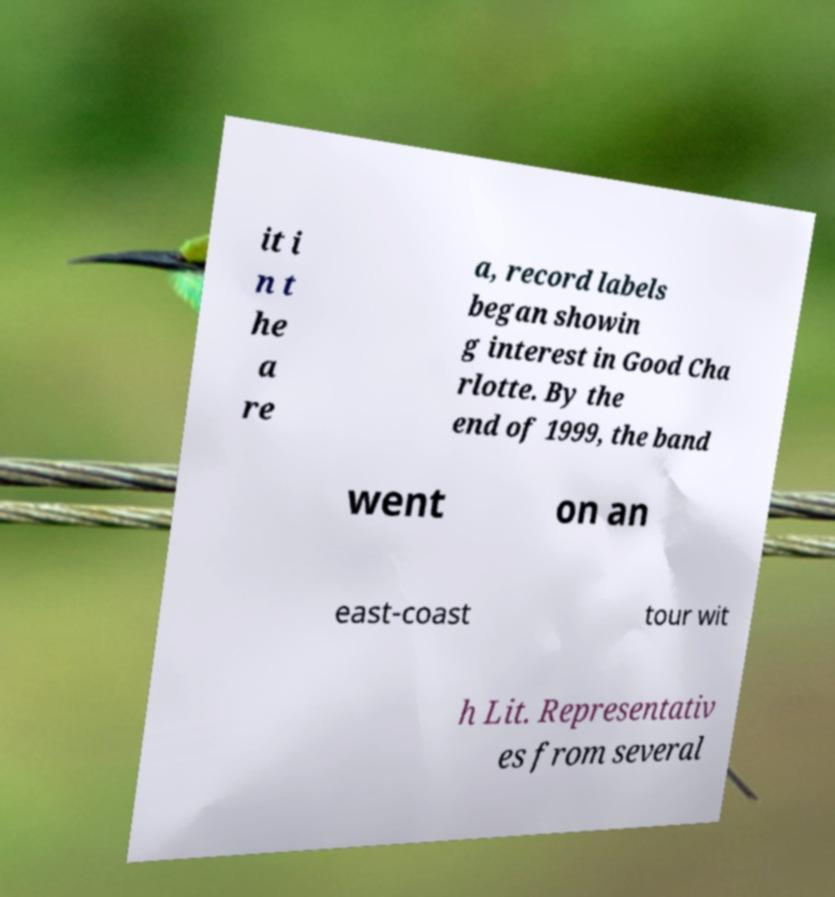Could you extract and type out the text from this image? it i n t he a re a, record labels began showin g interest in Good Cha rlotte. By the end of 1999, the band went on an east-coast tour wit h Lit. Representativ es from several 